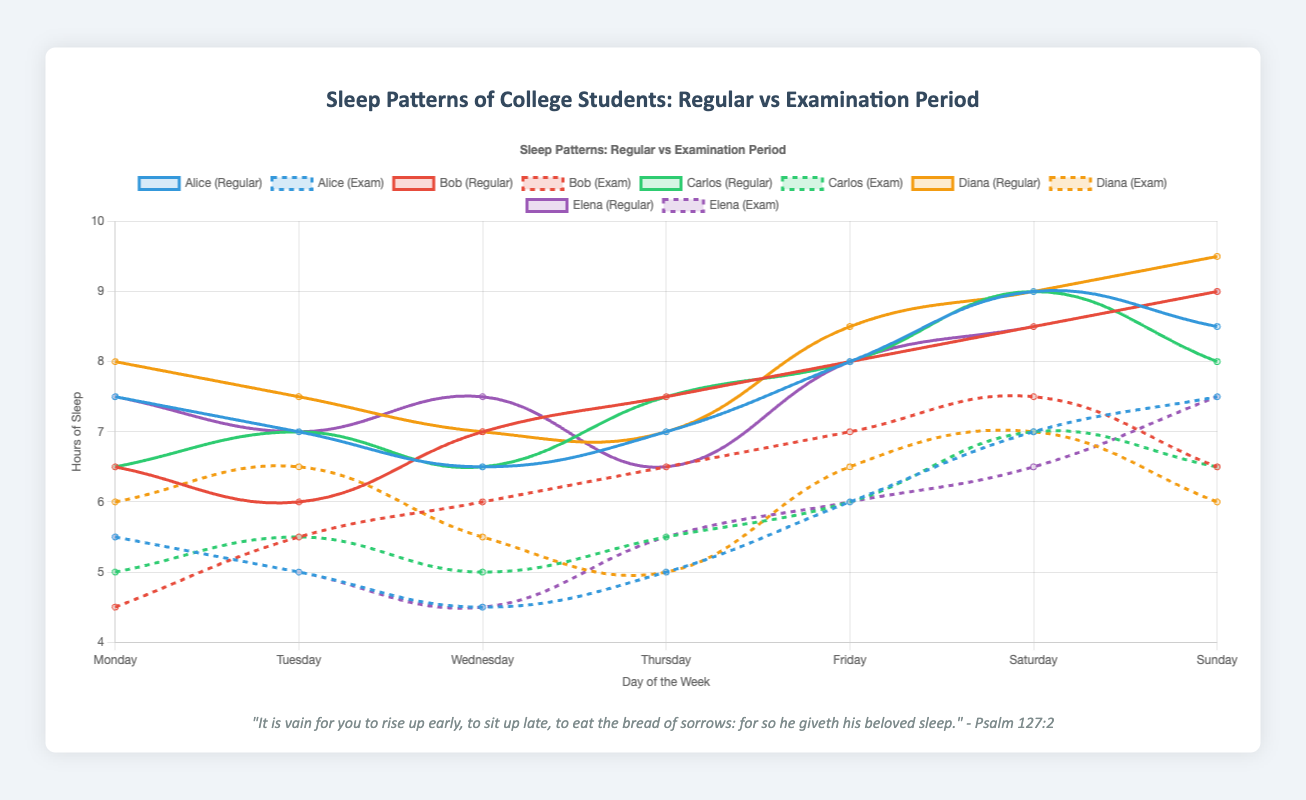What is the average number of hours Alice sleeps on weekdays during the examination period? To find the average number of hours Alice sleeps on weekdays during the examination period, sum the hours from Monday to Friday, which are 5.5, 5, 4.5, 5, and 6 respectively. The total is 5.5 + 5 + 4.5 + 5 + 6 = 26. Then divide by 5 (the number of weekdays), which gives 26 / 5 = 5.2.
Answer: 5.2 How does Diana's average sleep on weekends during the regular school period compare to the examination period? For the regular school period, Diana's weekend sleep hours (Saturday and Sunday) are 9 and 9.5 respectively, averaging (9 + 9.5) / 2 = 9.25. During the examination period, the weekend sleep hours are 7 and 6, averaging (7 + 6) / 2 = 6.5. Thus, 9.25 (regular) is greater than 6.5 (exam).
Answer: 9.25 > 6.5 Compare Bob's sleep hours on Wednesday during the regular school period and the examination period. On Wednesday, Bob sleeps 7 hours during the regular school period and 6 hours during the examination period. This indicates a decrease of 1 hour.
Answer: 1 hour less Which student shows the most significant decrease in sleep hours on average during the examination period compared to the regular school period? To determine this, we need to calculate the average sleep for each student during both periods and find the difference. Alice: Regular (7.5+7+6.5+7+8+9+8.5)/7 = 7.5, Exam (5.5+5+4.5+5+6+7+7.5)/7 = 5.64, Difference: 7.5-5.64=1.86 Bob: Regular (6.5+6+7+7.5+8+8.5+9)/7 = 7.5, Exam (4.5+5.5+6+6.5+7+7.5+6.5)/7 = 6.07, Difference: 7.5-6.07=1.43 Carlos: Regular (6.5+7+6.5+7.5+8+9+8)/7 = 7.36, Exam (5+5.5+5+5.5+6+7+6.5)/7 = 5.64, Difference: 7.36-5.64=1.72 Diana: Regular (8+7.5+7+7+8.5+9+9.5)/7 = 8.07, Exam (6+6.5+5.5+5+6.5+7+6)/7 = 6.07, Difference: 8.07-6.07=2 Elena: Regular (7.5+7+7.5+6.5+8+8.5+9)/7 = 7.71, Exam (5.5+5+4.5+5.5+6+6.5+7.5)/7 = 5.64, Difference: 7.71-5.64=2.07. Among them, Elena shows the most significant decrease.
Answer: Elena 